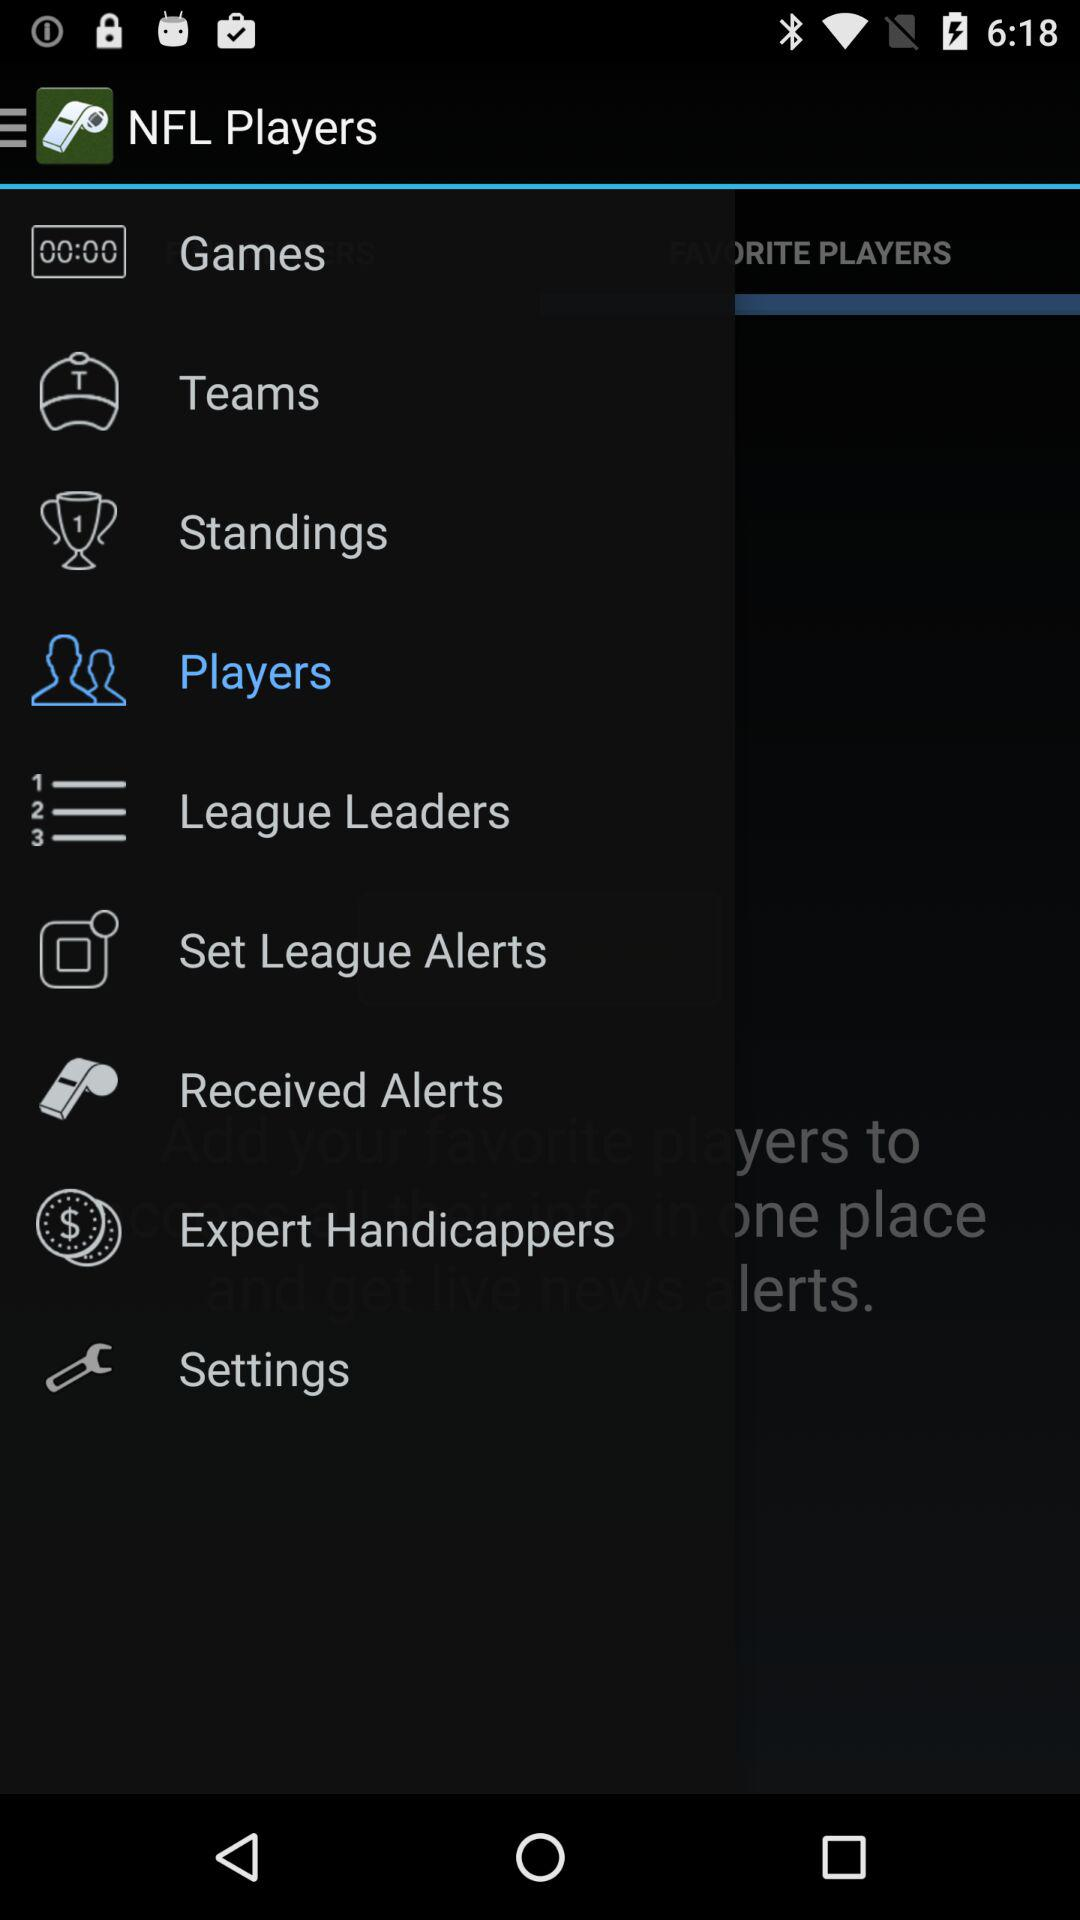What is the application name? The application name is "NFL Players". 